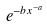Convert formula to latex. <formula><loc_0><loc_0><loc_500><loc_500>e ^ { - b x ^ { - a } }</formula> 